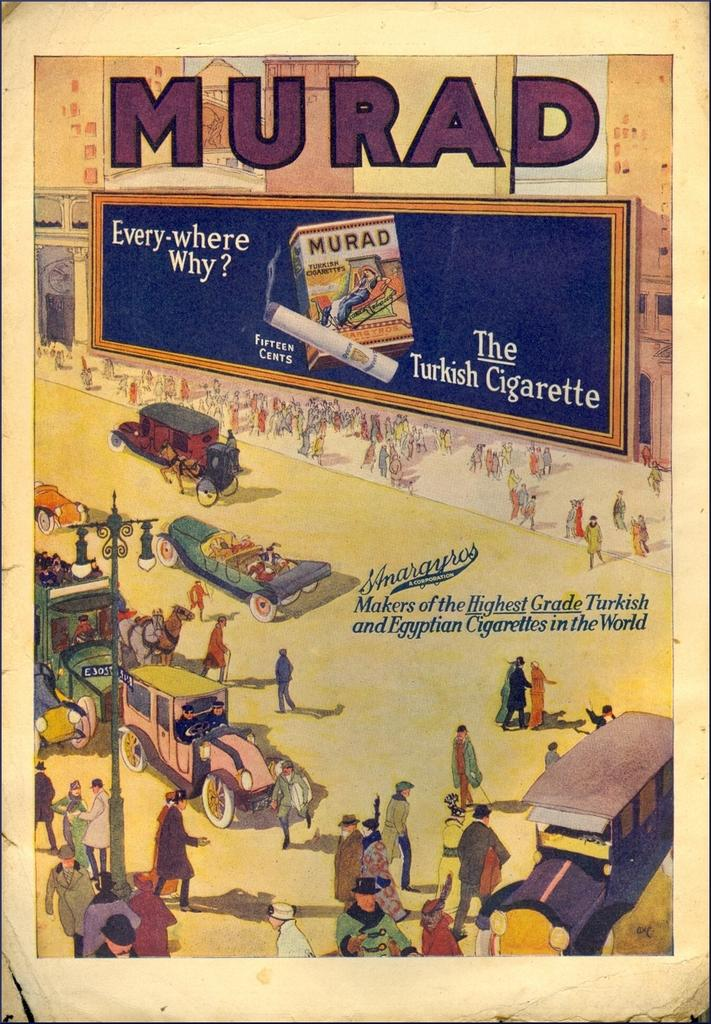<image>
Offer a succinct explanation of the picture presented. an old street scene poster for MURAD The Turkish Cigarette 